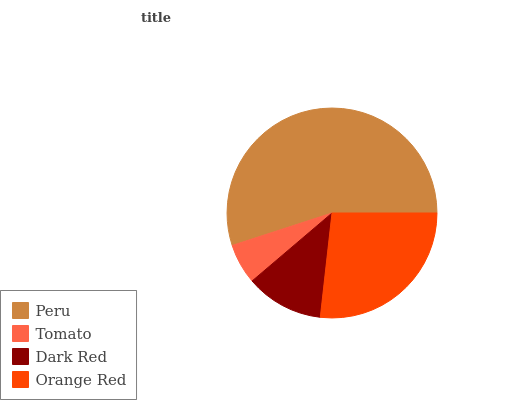Is Tomato the minimum?
Answer yes or no. Yes. Is Peru the maximum?
Answer yes or no. Yes. Is Dark Red the minimum?
Answer yes or no. No. Is Dark Red the maximum?
Answer yes or no. No. Is Dark Red greater than Tomato?
Answer yes or no. Yes. Is Tomato less than Dark Red?
Answer yes or no. Yes. Is Tomato greater than Dark Red?
Answer yes or no. No. Is Dark Red less than Tomato?
Answer yes or no. No. Is Orange Red the high median?
Answer yes or no. Yes. Is Dark Red the low median?
Answer yes or no. Yes. Is Dark Red the high median?
Answer yes or no. No. Is Peru the low median?
Answer yes or no. No. 